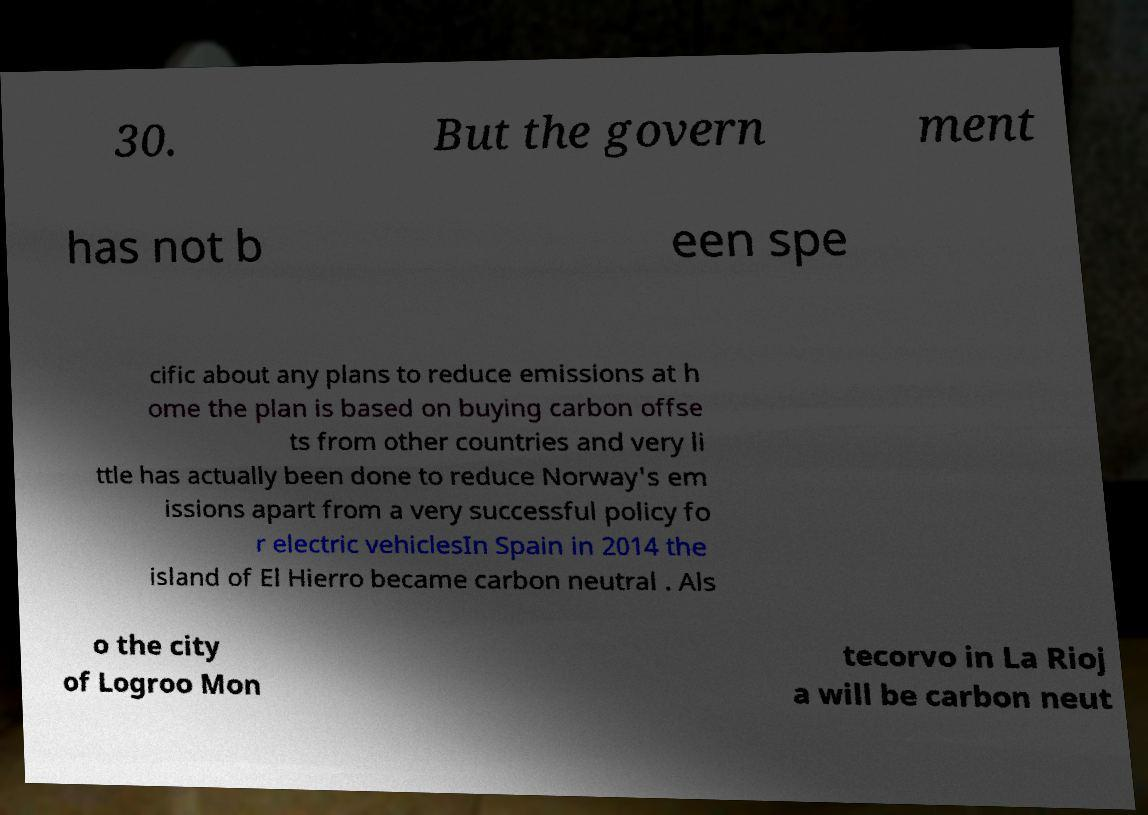Can you read and provide the text displayed in the image?This photo seems to have some interesting text. Can you extract and type it out for me? 30. But the govern ment has not b een spe cific about any plans to reduce emissions at h ome the plan is based on buying carbon offse ts from other countries and very li ttle has actually been done to reduce Norway's em issions apart from a very successful policy fo r electric vehiclesIn Spain in 2014 the island of El Hierro became carbon neutral . Als o the city of Logroo Mon tecorvo in La Rioj a will be carbon neut 